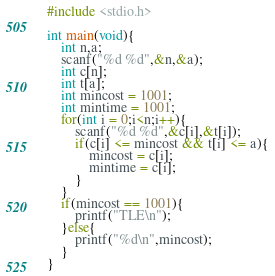<code> <loc_0><loc_0><loc_500><loc_500><_C_>#include <stdio.h>

int main(void){
    int n,a;
    scanf("%d %d",&n,&a);
    int c[n];
    int t[a];
    int mincost = 1001;
    int mintime = 1001;
    for(int i = 0;i<n;i++){
        scanf("%d %d",&c[i],&t[i]);
        if(c[i] <= mincost && t[i] <= a){
            mincost = c[i];
            mintime = c[i];
        }
    }
    if(mincost == 1001){
        printf("TLE\n");
    }else{
        printf("%d\n",mincost);
    }
}</code> 